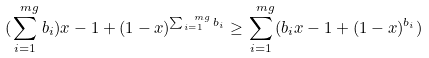<formula> <loc_0><loc_0><loc_500><loc_500>( \sum _ { i = 1 } ^ { \ m g } b _ { i } ) x - 1 + ( 1 - x ) ^ { \sum _ { i = 1 } ^ { \ m g } b _ { i } } \geq \sum _ { i = 1 } ^ { \ m g } ( b _ { i } x - 1 + ( 1 - x ) ^ { b _ { i } } )</formula> 